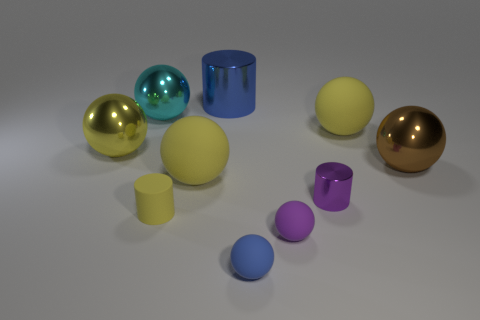What shape is the large shiny object that is to the right of the cylinder that is behind the yellow matte thing on the right side of the tiny purple metal cylinder?
Give a very brief answer. Sphere. The small shiny thing that is the same shape as the big blue object is what color?
Your answer should be compact. Purple. There is a large ball behind the large yellow sphere on the right side of the small purple shiny object; what color is it?
Offer a terse response. Cyan. There is a purple object that is the same shape as the tiny yellow rubber object; what is its size?
Give a very brief answer. Small. How many tiny yellow objects are made of the same material as the cyan sphere?
Your answer should be compact. 0. There is a yellow ball left of the small yellow cylinder; what number of tiny yellow cylinders are to the left of it?
Offer a terse response. 0. Are there any large yellow objects right of the small purple sphere?
Your answer should be very brief. Yes. There is a thing on the left side of the big cyan metal sphere; does it have the same shape as the big cyan thing?
Make the answer very short. Yes. There is a ball that is the same color as the small metal object; what material is it?
Your answer should be compact. Rubber. What number of small matte balls are the same color as the tiny metal thing?
Provide a short and direct response. 1. 